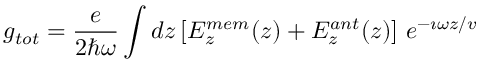Convert formula to latex. <formula><loc_0><loc_0><loc_500><loc_500>g _ { t o t } = \frac { e } { 2 \hbar { \omega } } \int d z \left [ E _ { z } ^ { m e m } ( z ) + E _ { z } ^ { a n t } ( z ) \right ] \, e ^ { - \imath \omega z / v }</formula> 